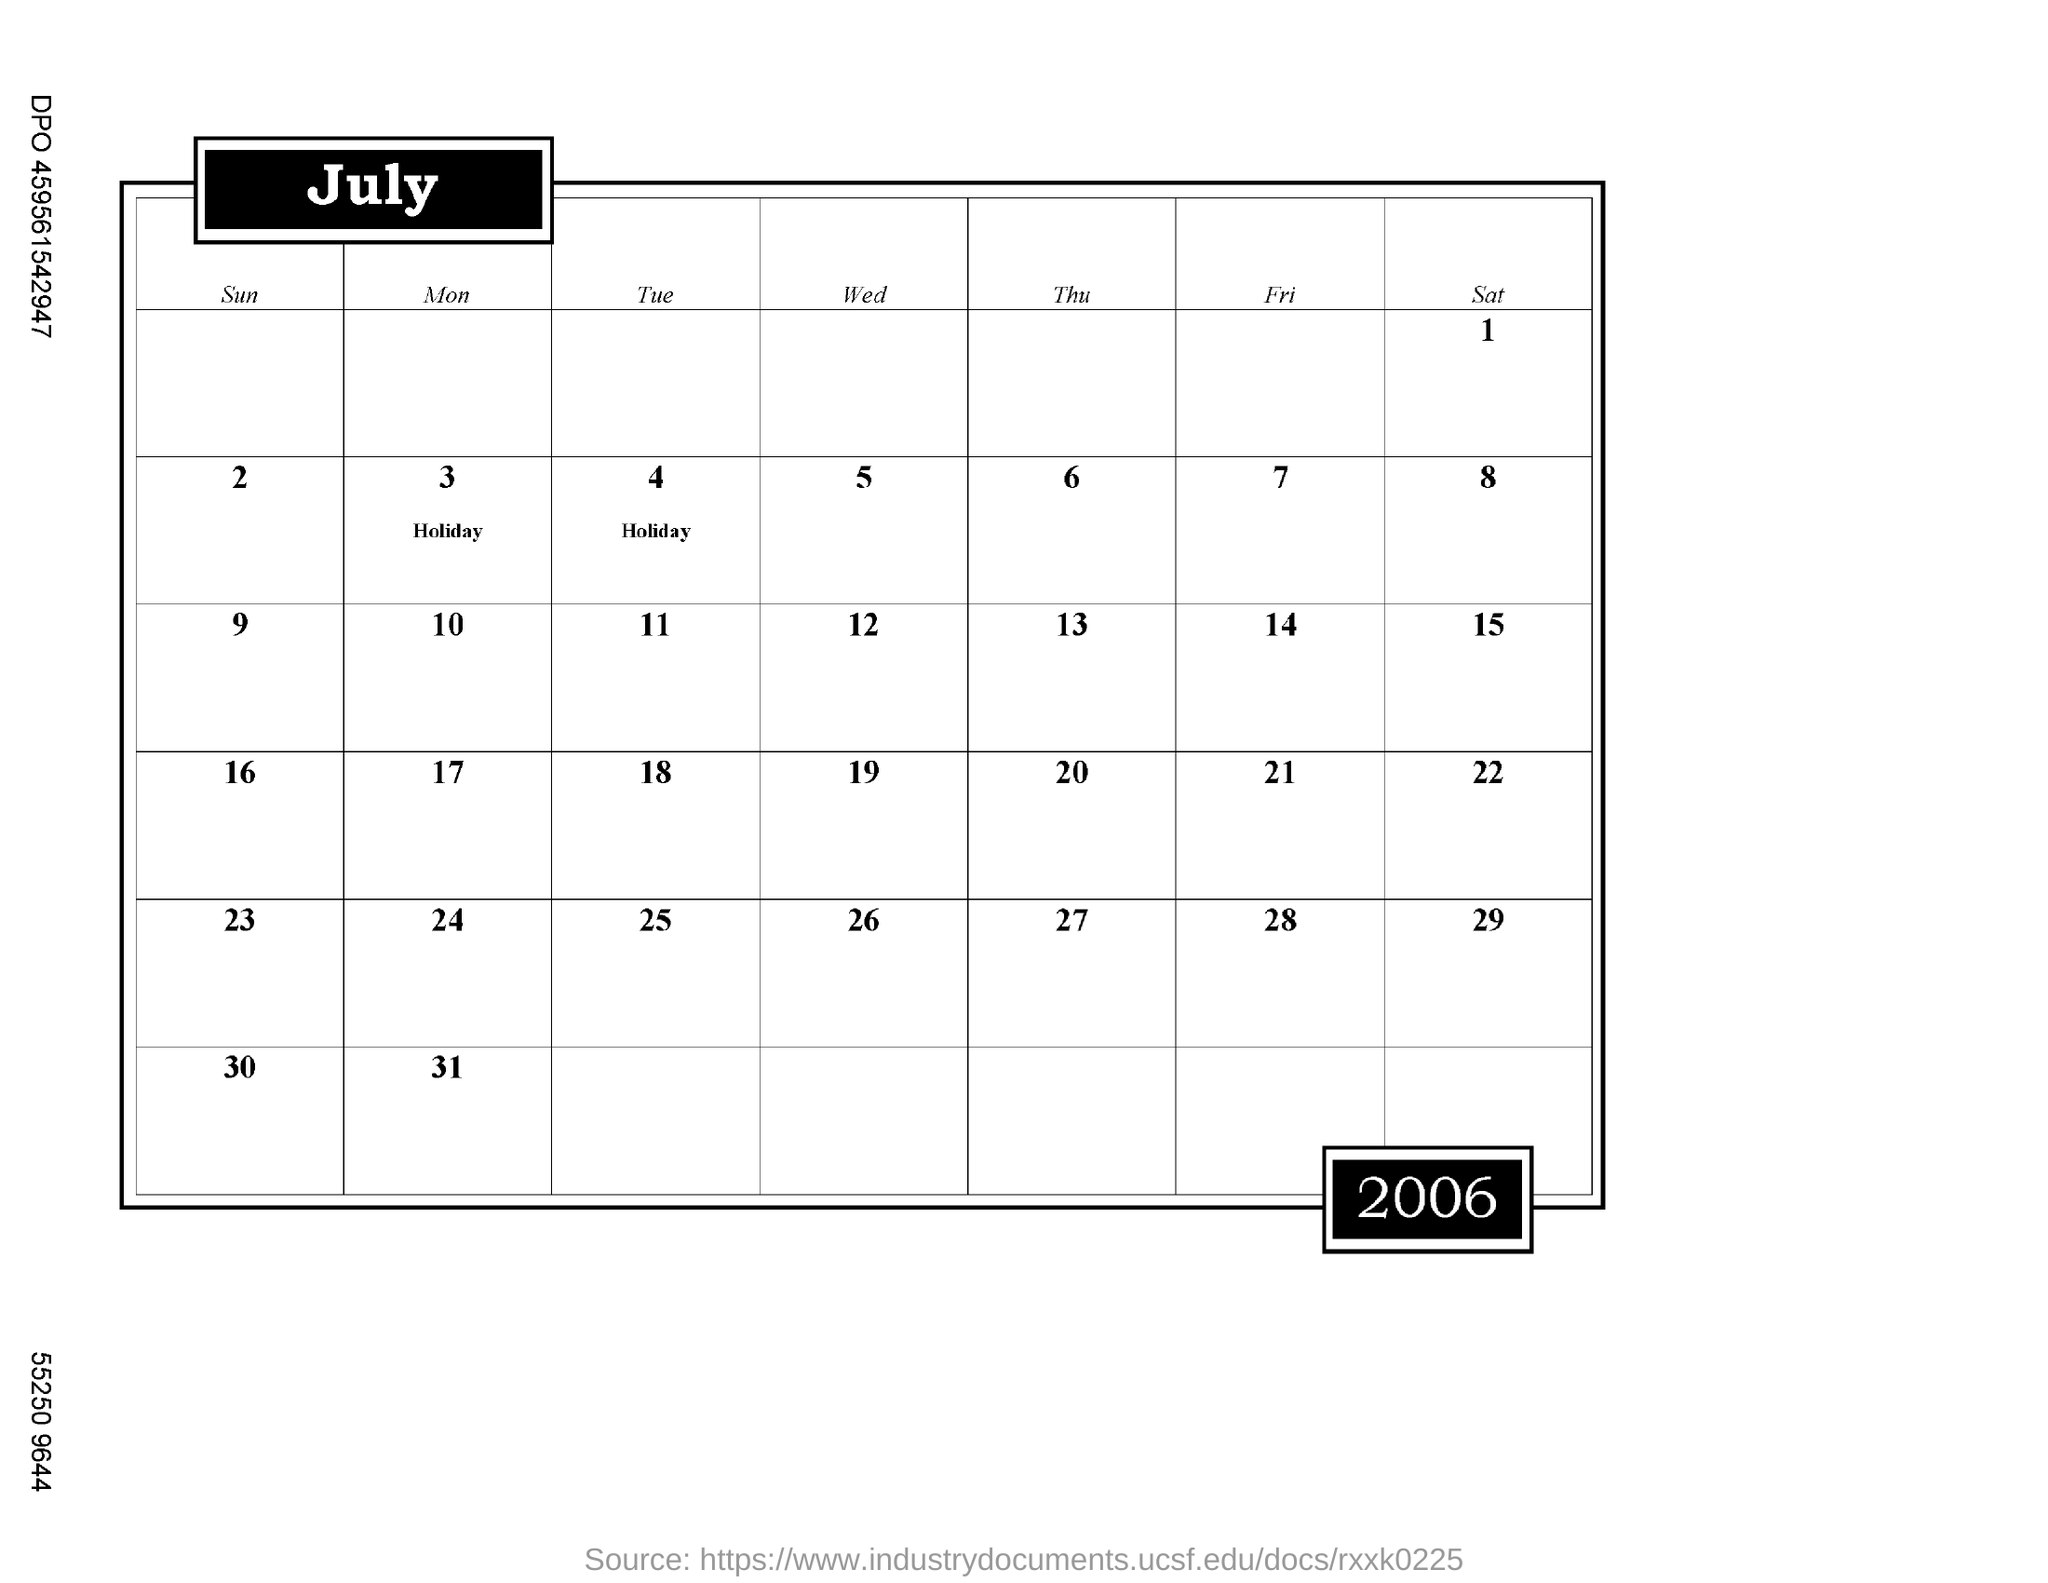Give some essential details in this illustration. The question asks which month's calendar this is referring to, specifically July. The first holiday date is marked on the calendar on the third of the month. There are 31 days in July 2006. The second holiday date is marked in the calendar on January 4th. What is the date of the second Saturday of this month? 